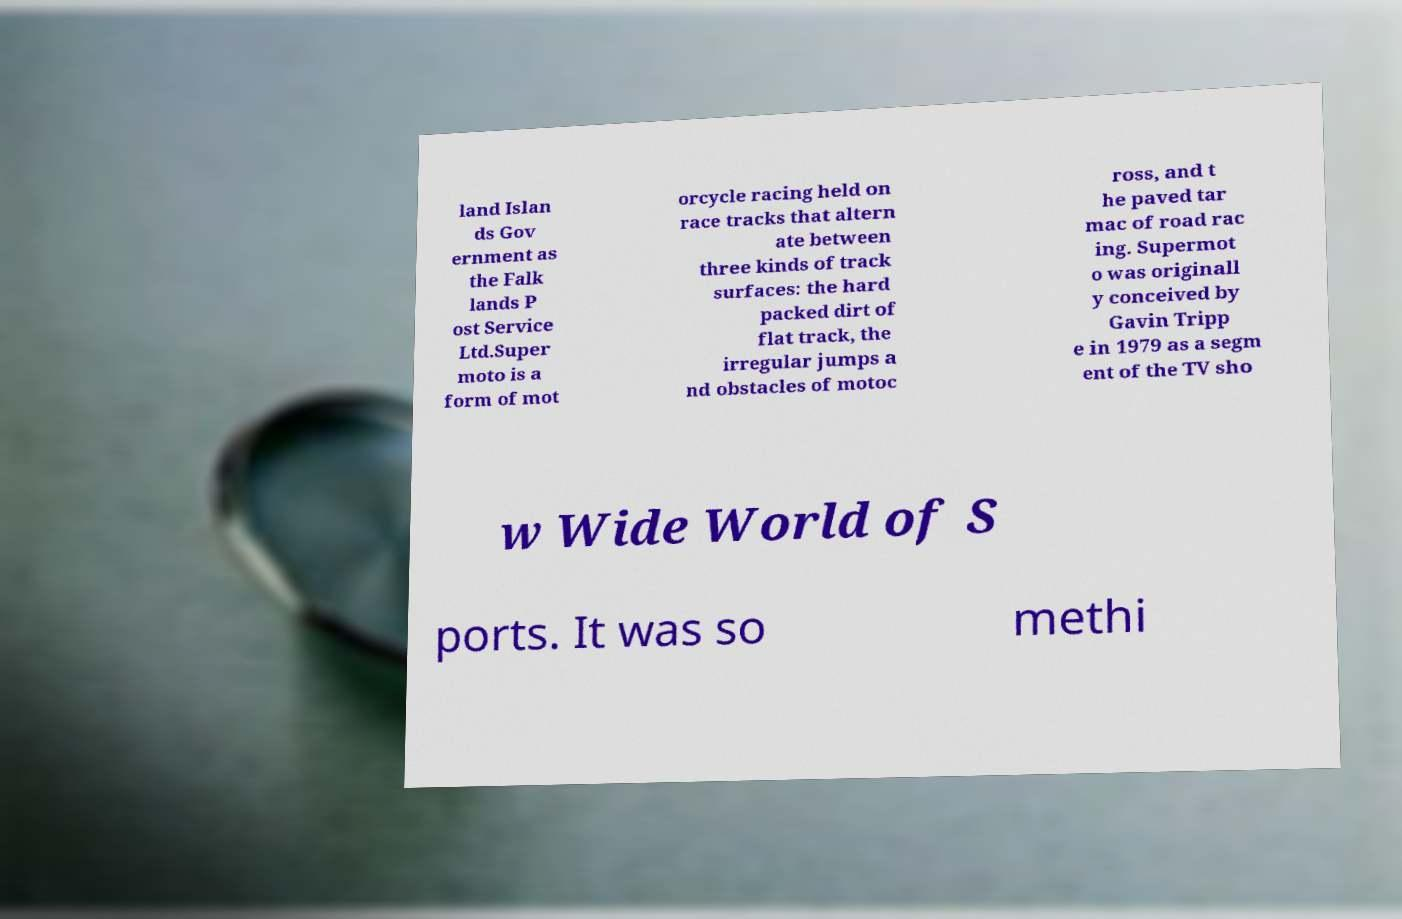There's text embedded in this image that I need extracted. Can you transcribe it verbatim? land Islan ds Gov ernment as the Falk lands P ost Service Ltd.Super moto is a form of mot orcycle racing held on race tracks that altern ate between three kinds of track surfaces: the hard packed dirt of flat track, the irregular jumps a nd obstacles of motoc ross, and t he paved tar mac of road rac ing. Supermot o was originall y conceived by Gavin Tripp e in 1979 as a segm ent of the TV sho w Wide World of S ports. It was so methi 